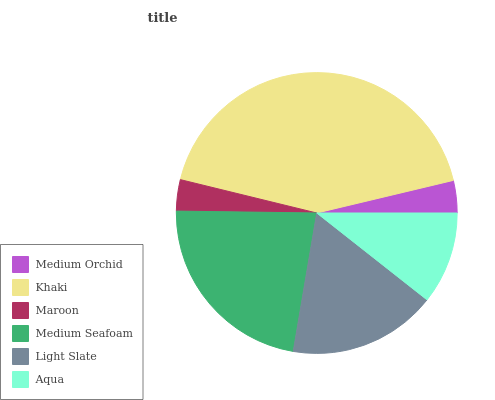Is Maroon the minimum?
Answer yes or no. Yes. Is Khaki the maximum?
Answer yes or no. Yes. Is Khaki the minimum?
Answer yes or no. No. Is Maroon the maximum?
Answer yes or no. No. Is Khaki greater than Maroon?
Answer yes or no. Yes. Is Maroon less than Khaki?
Answer yes or no. Yes. Is Maroon greater than Khaki?
Answer yes or no. No. Is Khaki less than Maroon?
Answer yes or no. No. Is Light Slate the high median?
Answer yes or no. Yes. Is Aqua the low median?
Answer yes or no. Yes. Is Aqua the high median?
Answer yes or no. No. Is Maroon the low median?
Answer yes or no. No. 